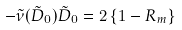<formula> <loc_0><loc_0><loc_500><loc_500>- \tilde { \nu } ( \tilde { D } _ { 0 } ) \tilde { D } _ { 0 } = 2 \left \{ 1 - R _ { m } \right \}</formula> 